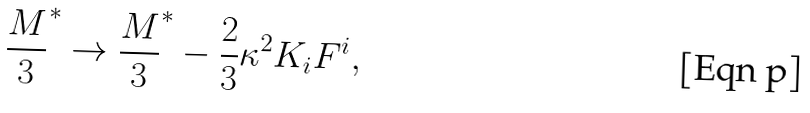<formula> <loc_0><loc_0><loc_500><loc_500>\frac { M } { 3 } ^ { * } \rightarrow \frac { M } { 3 } ^ { * } - \frac { 2 } { 3 } \kappa ^ { 2 } K _ { i } F ^ { i } ,</formula> 